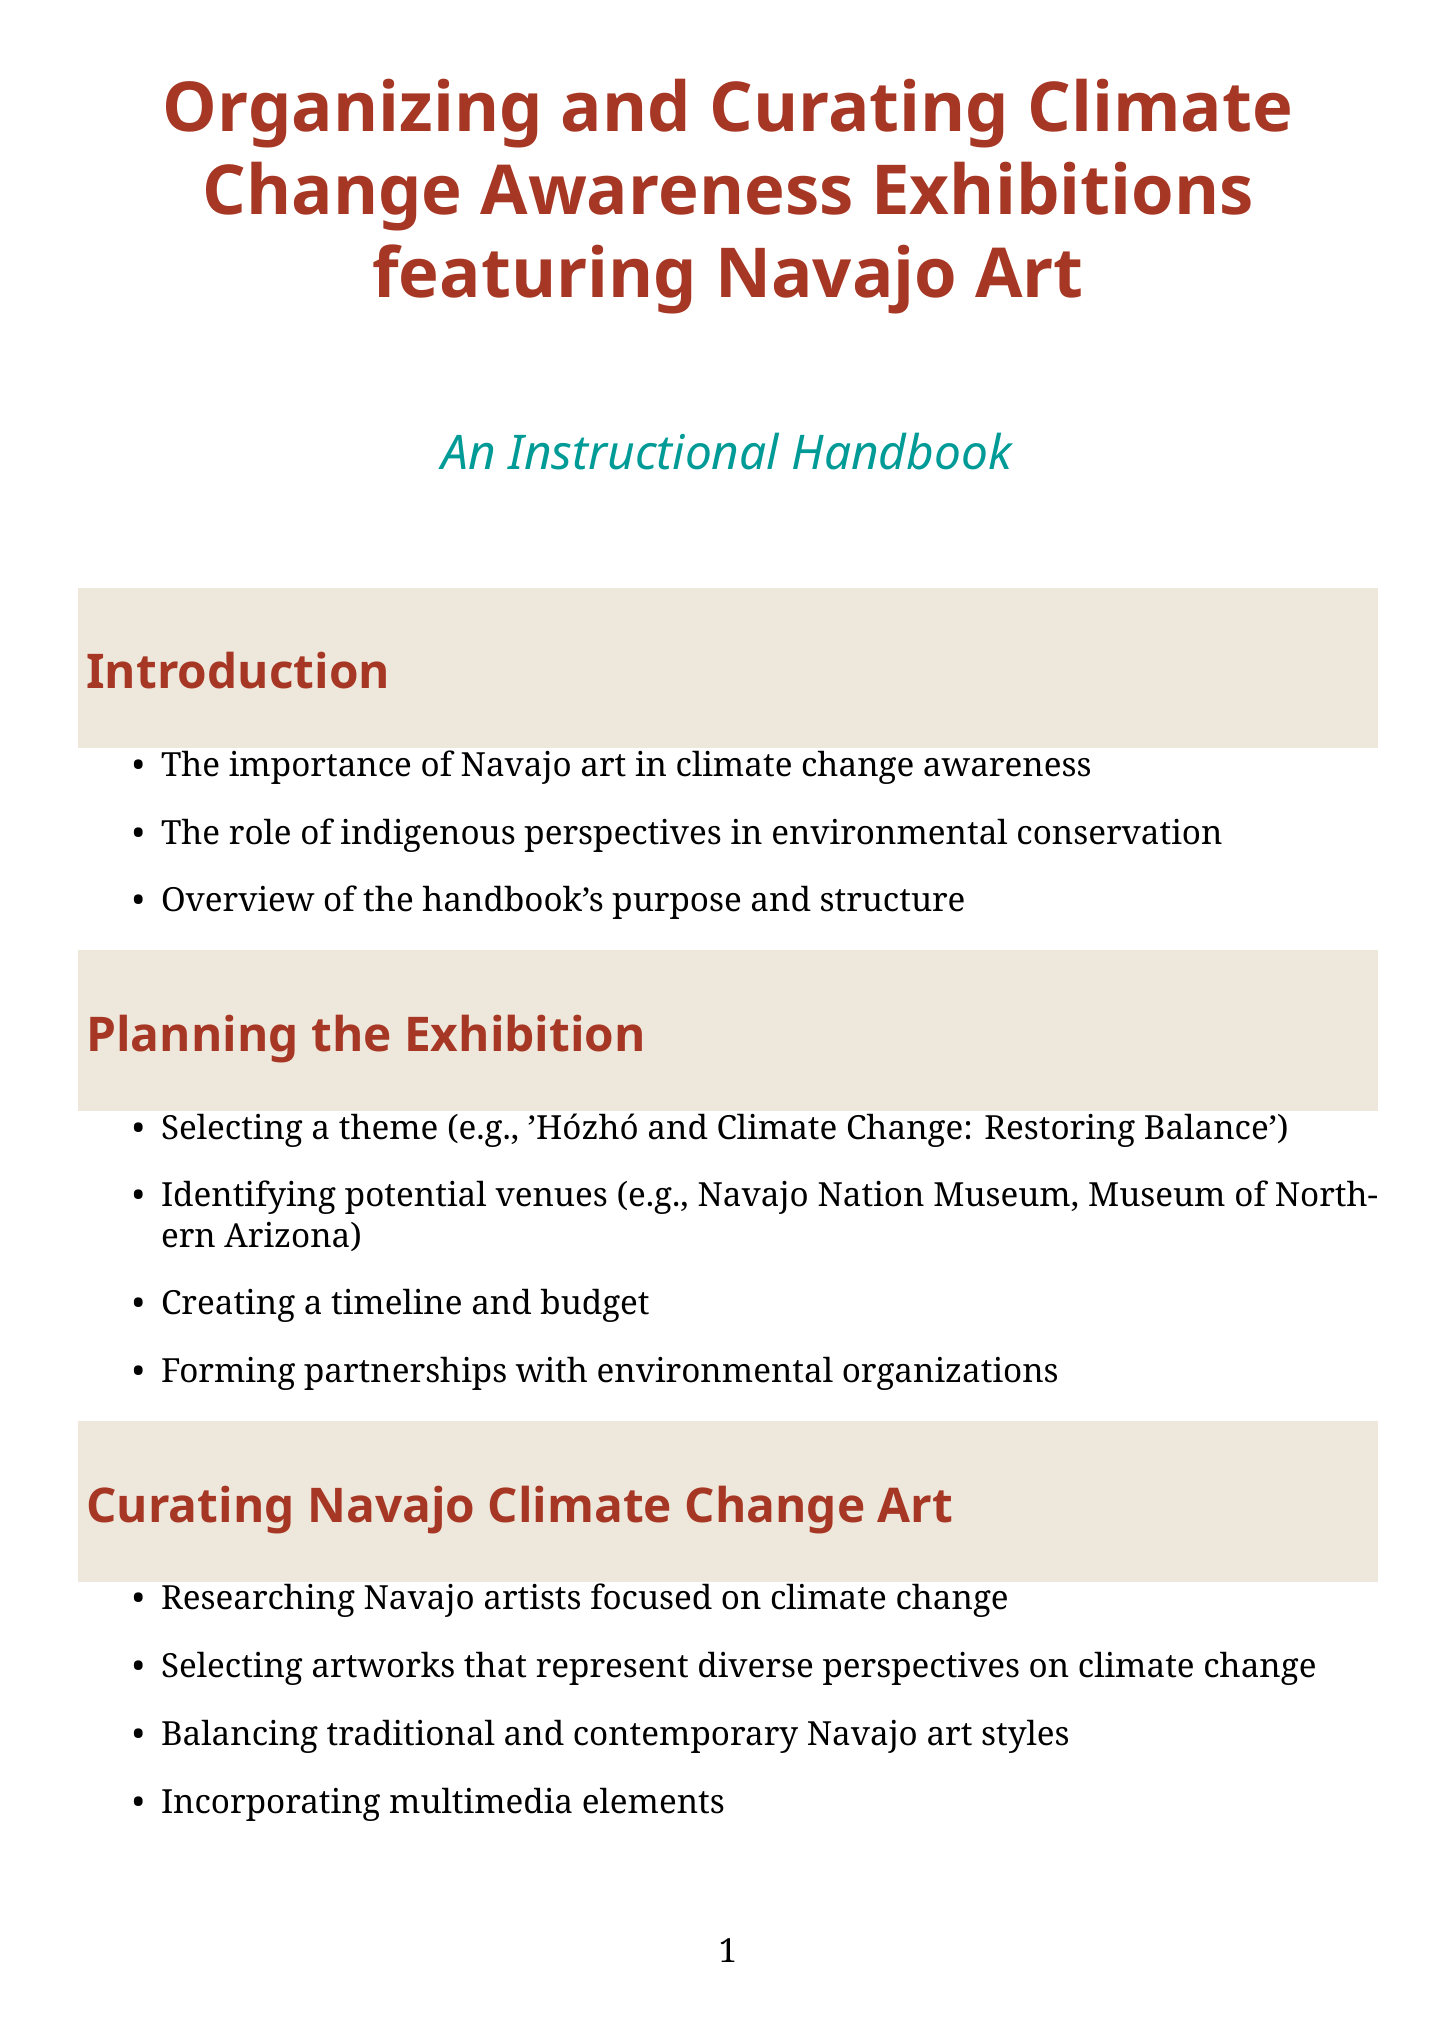What is the title of the handbook? The title of the handbook is clearly stated at the beginning of the document.
Answer: Organizing and Curating Climate Change Awareness Exhibitions featuring Navajo Art: An Instructional Handbook What is one identified potential venue for the exhibition? The document lists specific venues in the "Planning the Exhibition" section.
Answer: Navajo Nation Museum Who is an example of a Navajo artist focused on climate change? Examples of Navajo artists are provided in the "Curating Navajo Climate Change Art" section.
Answer: Venaya Yazzie Which element is mentioned for incorporating interactive components? The "Exhibition Design and Layout" section discusses various elements to include.
Answer: Augmented reality experiences What is a suggested theme for the exhibition? The document recommends a specific theme in the planning section.
Answer: Hózhó and Climate Change: Restoring Balance How should the exhibition address sustainability? The "Sustainability Practices" section outlines eco-friendly strategies.
Answer: Using eco-friendly materials What types of public engagement activities are suggested? The "Community Engagement" section outlines activities to foster community involvement.
Answer: Community art-making sessions What should be documented for evaluation purposes? The "Documentation and Evaluation" section notes what should be included for assessing the exhibition's success.
Answer: Catalog of exhibited artworks 